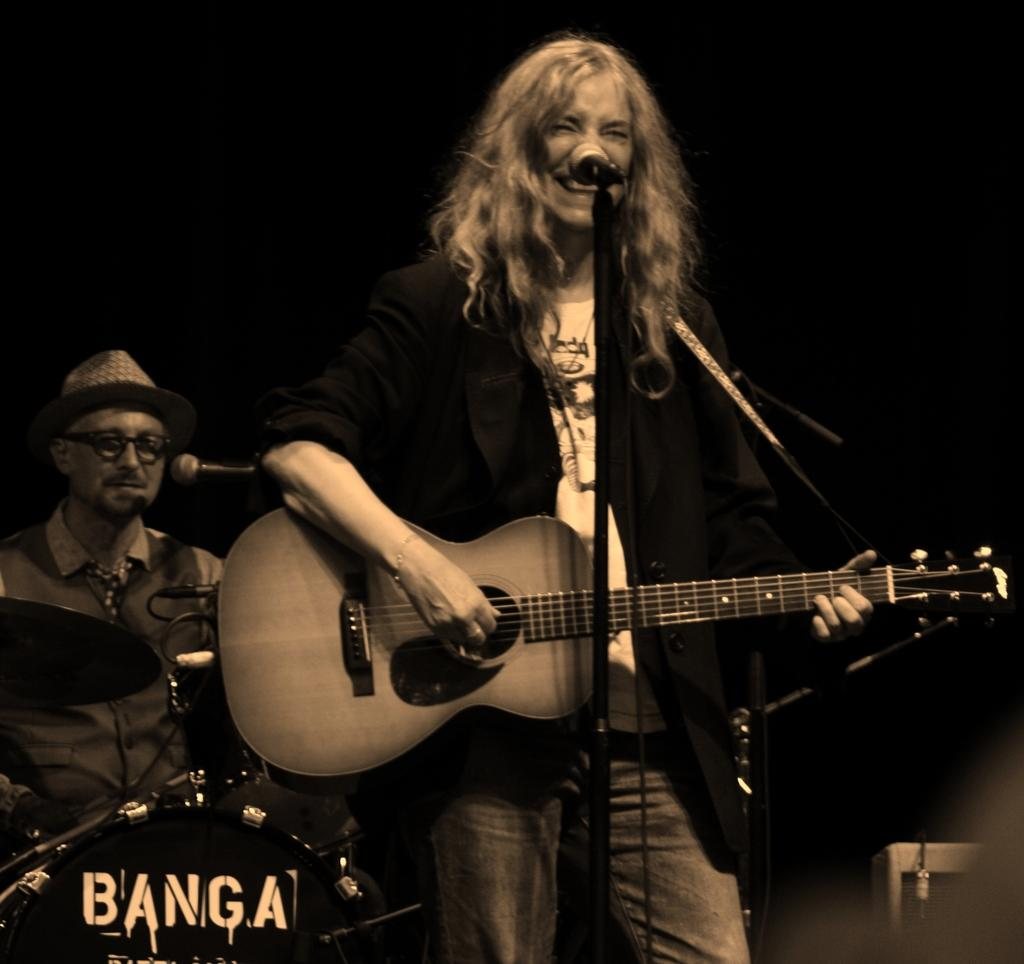Who is the main subject in the image? There is a woman in the image. What is the woman doing in the image? The woman is standing and playing a guitar. What equipment is present for the woman to use in the image? There is a microphone and a mic stand in the image. Who else is present in the image? There is a man in the image. What is the man doing in the image? The man is sitting and playing the drums. How is the man's drum set positioned in the image? The background of the image includes the man playing the drums. What type of rail can be seen in the image? There is no rail present in the image. What kind of horn is being played by the woman in the image? The woman is playing a guitar, not a horn, in the image. 